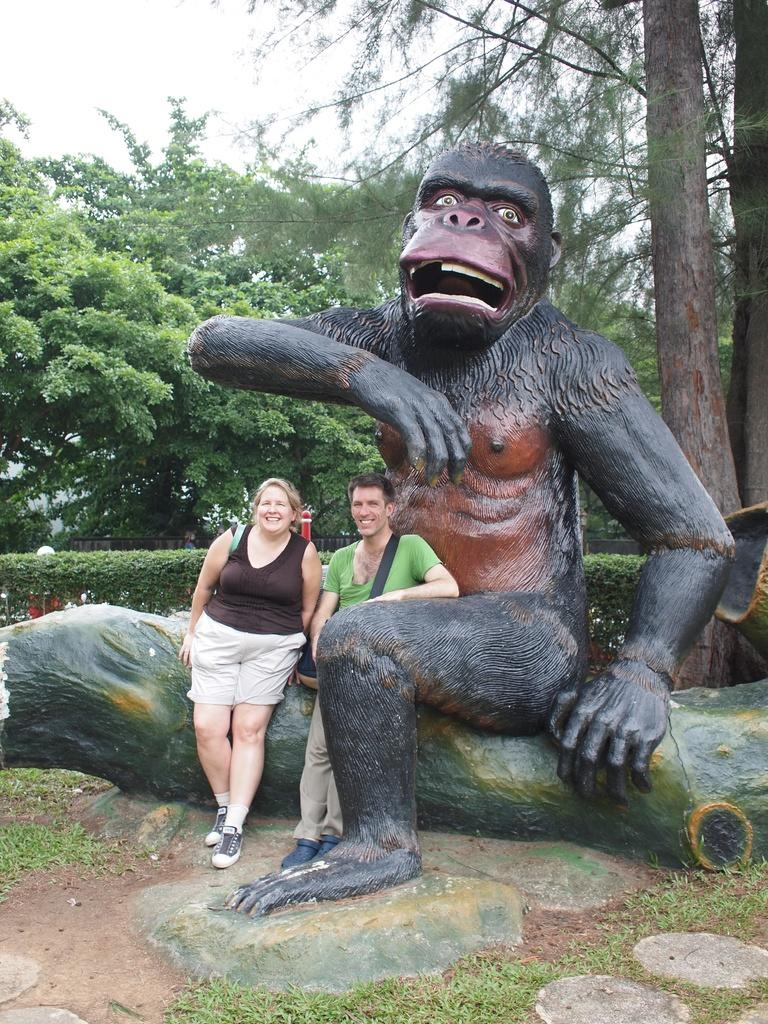What is the main subject in the center of the image? There is a depiction of a gorilla in the center of the image. How many people are present in the image? There are two persons standing in the image. What can be seen in the background of the image? There are trees in the background of the image. What is the condition of the son in the image? There is no son present in the image. Is there an arch visible in the image? There is no arch visible in the image. 